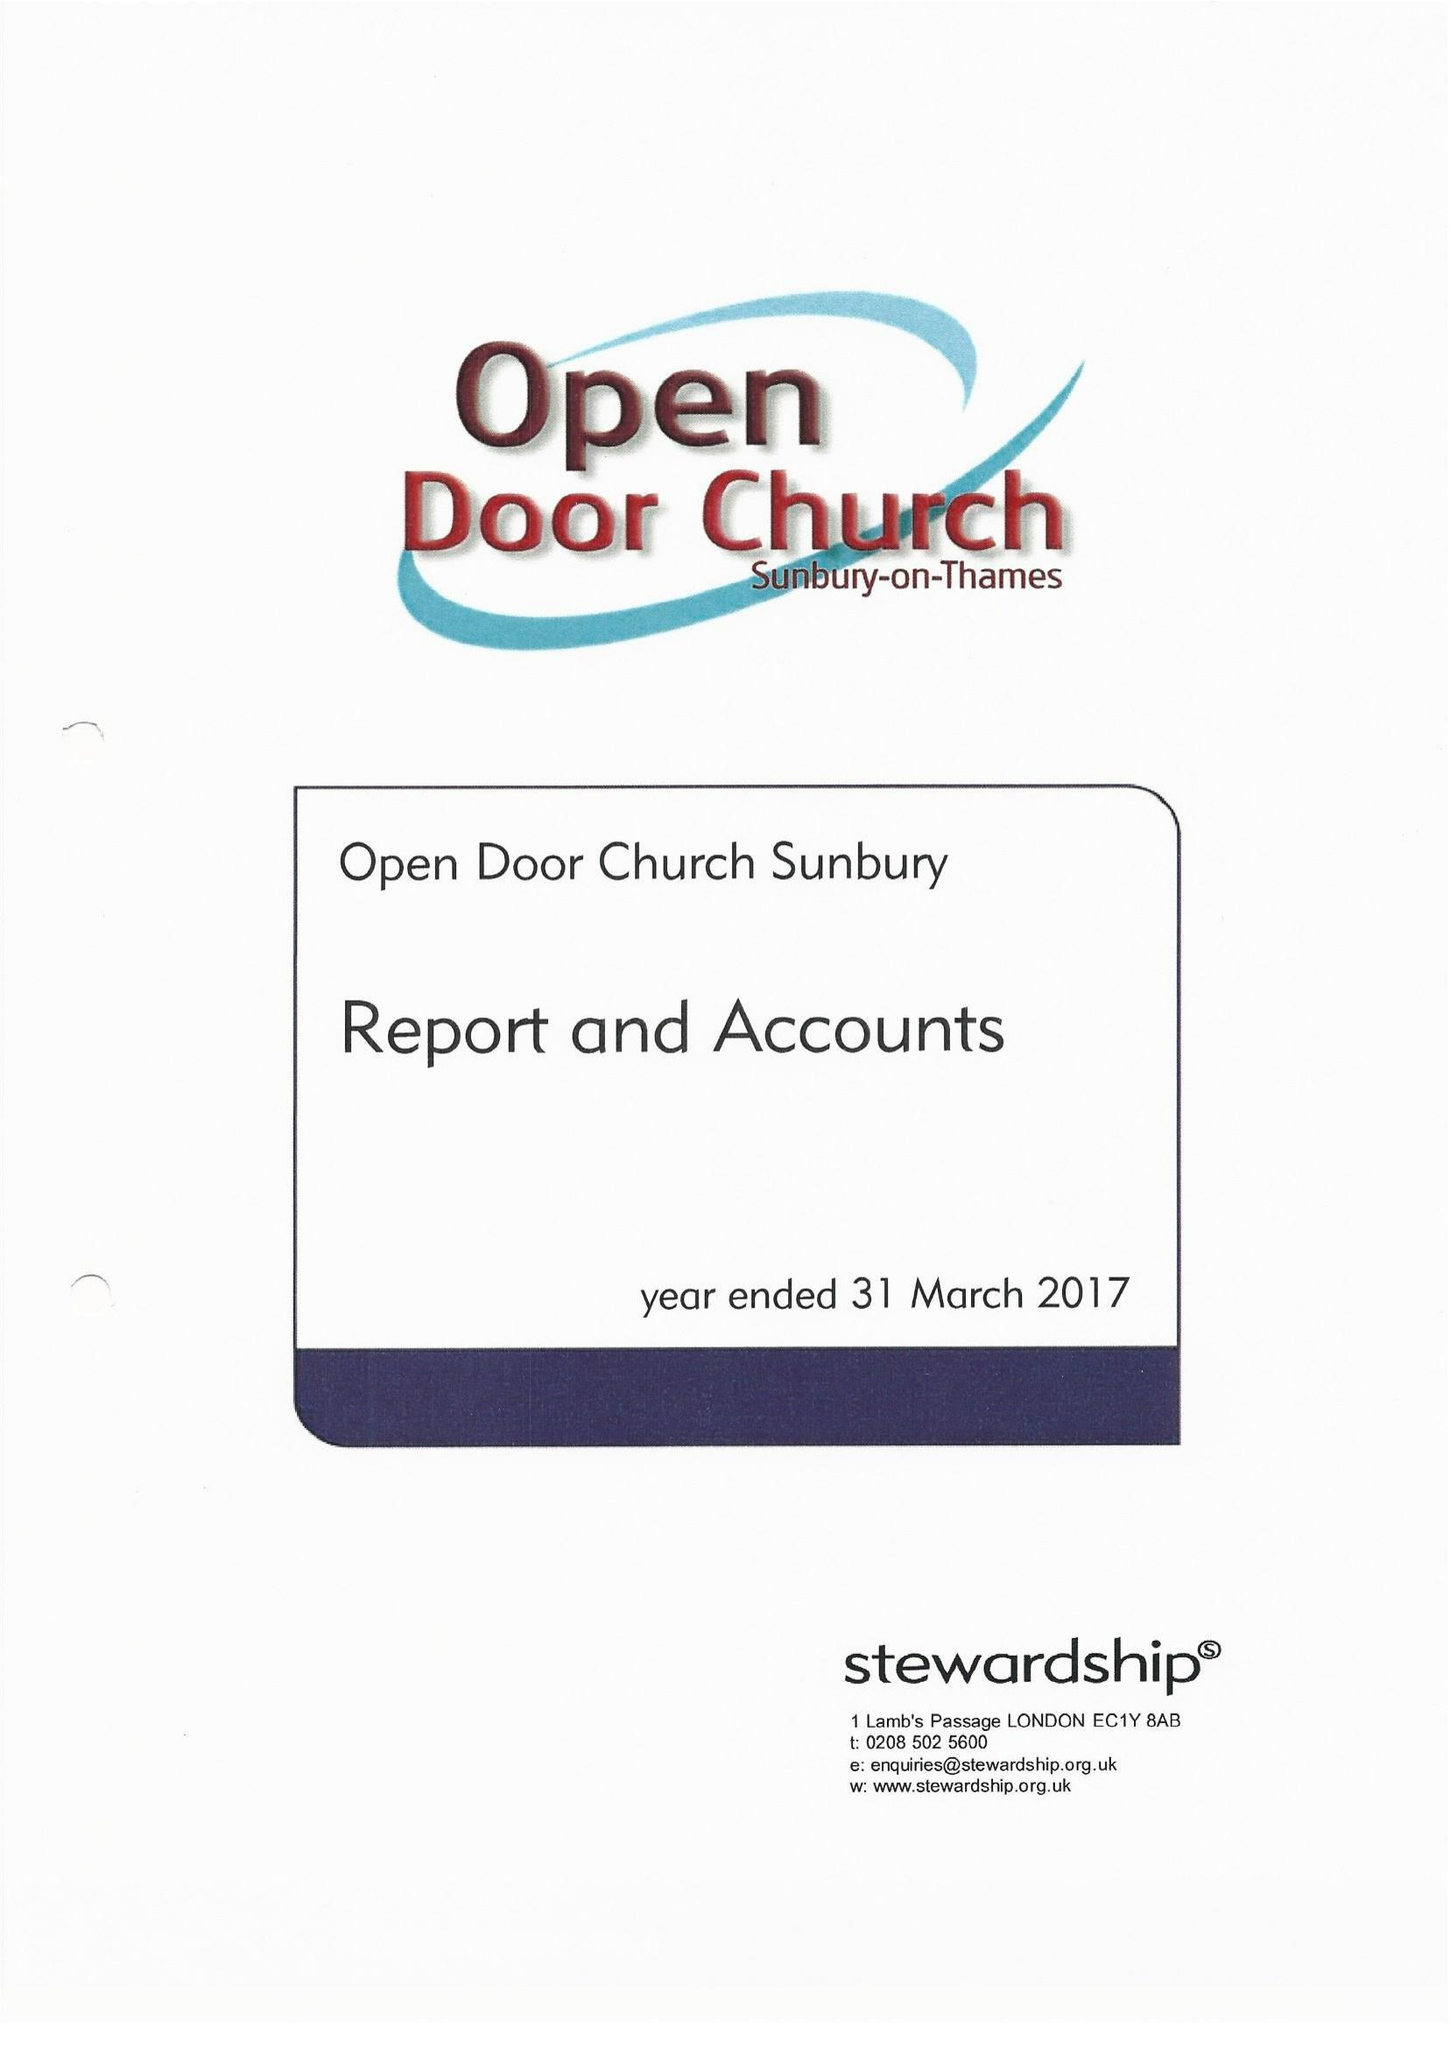What is the value for the address__postcode?
Answer the question using a single word or phrase. TW16 6QQ 